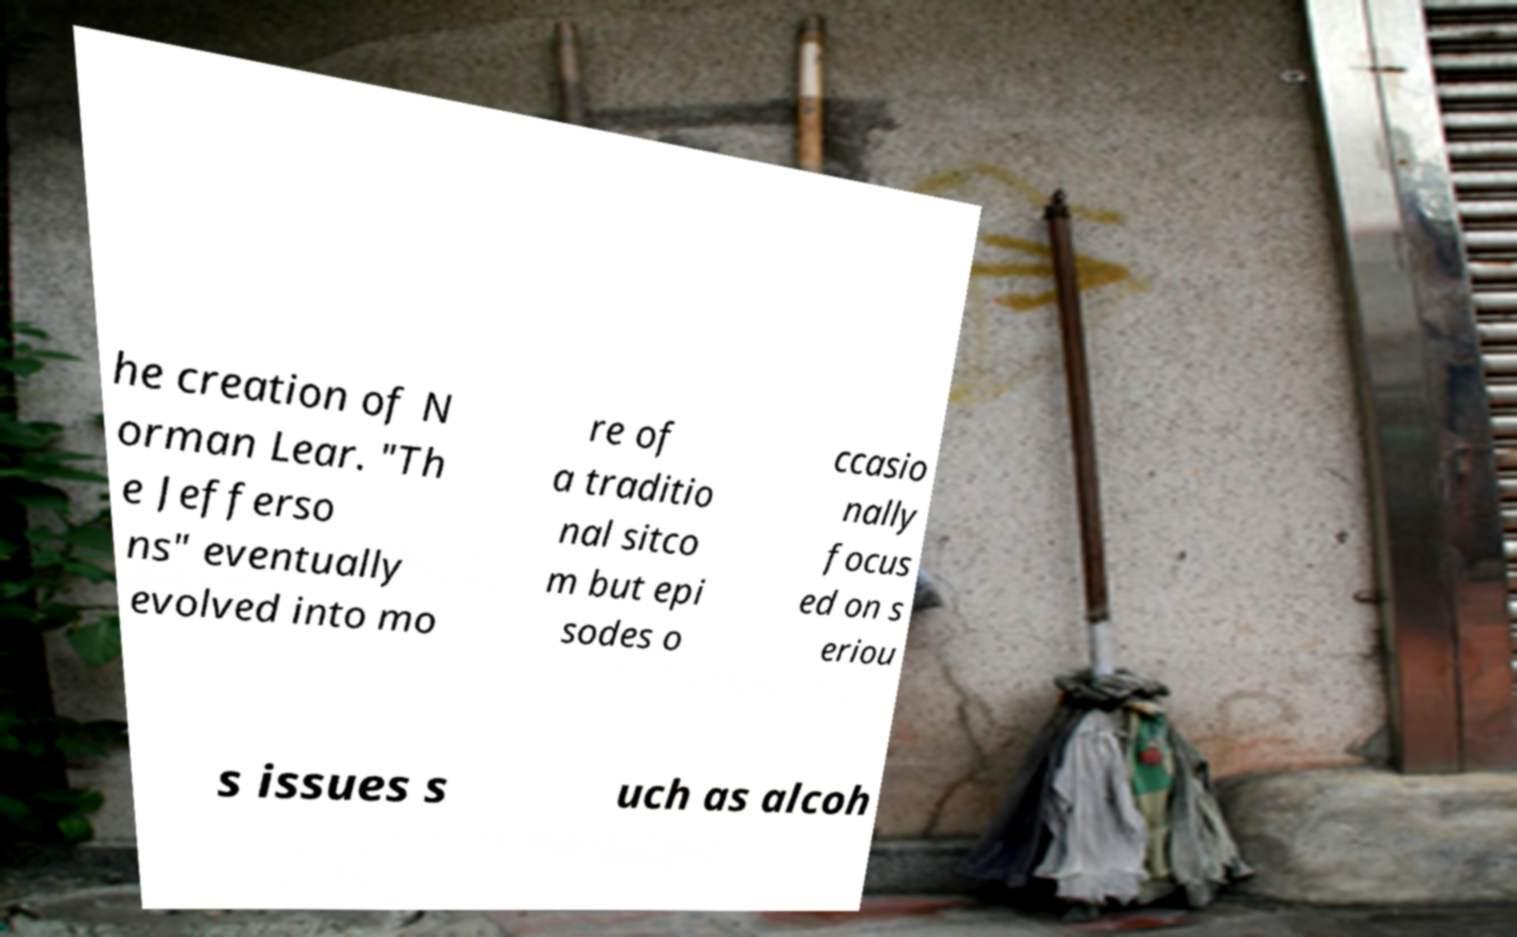Can you read and provide the text displayed in the image?This photo seems to have some interesting text. Can you extract and type it out for me? he creation of N orman Lear. "Th e Jefferso ns" eventually evolved into mo re of a traditio nal sitco m but epi sodes o ccasio nally focus ed on s eriou s issues s uch as alcoh 